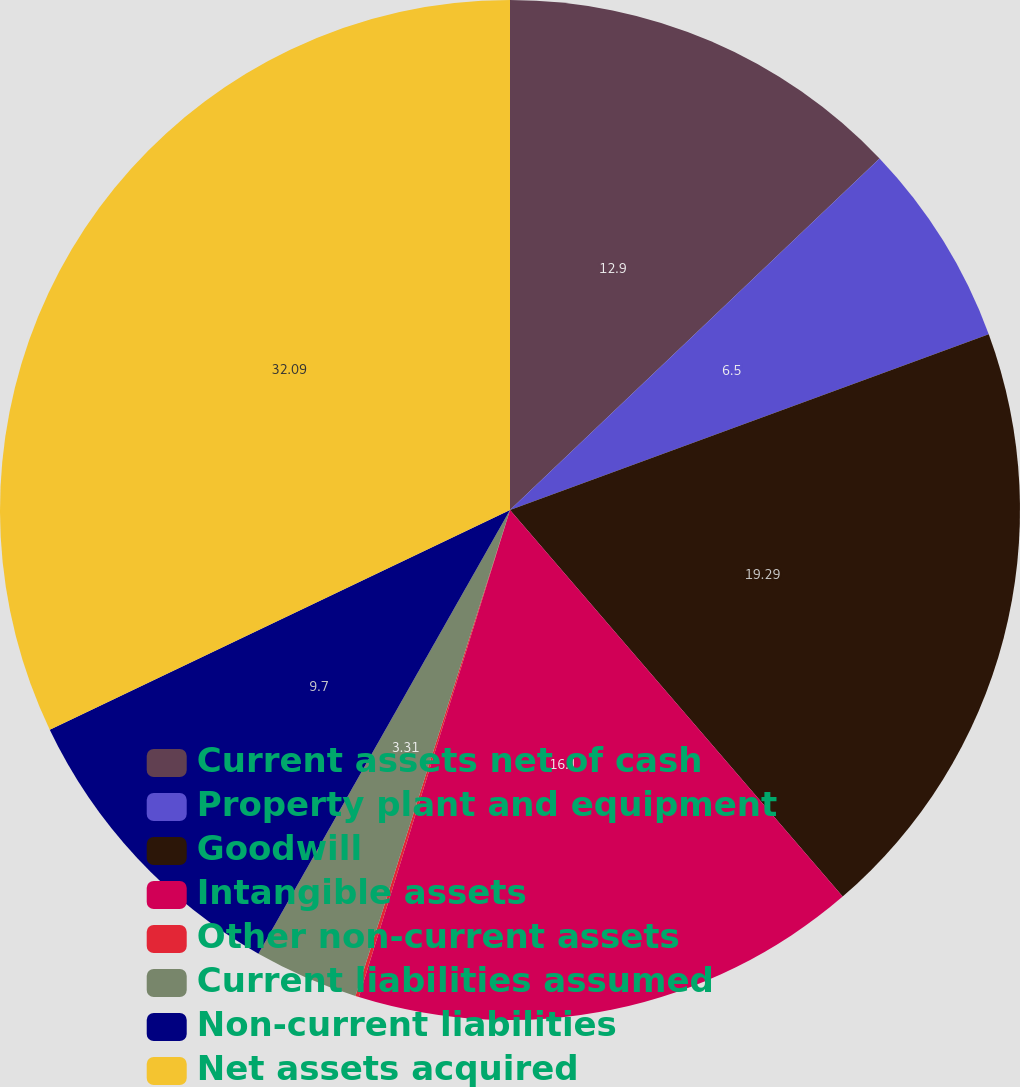Convert chart. <chart><loc_0><loc_0><loc_500><loc_500><pie_chart><fcel>Current assets net of cash<fcel>Property plant and equipment<fcel>Goodwill<fcel>Intangible assets<fcel>Other non-current assets<fcel>Current liabilities assumed<fcel>Non-current liabilities<fcel>Net assets acquired<nl><fcel>12.9%<fcel>6.5%<fcel>19.29%<fcel>16.1%<fcel>0.11%<fcel>3.31%<fcel>9.7%<fcel>32.09%<nl></chart> 